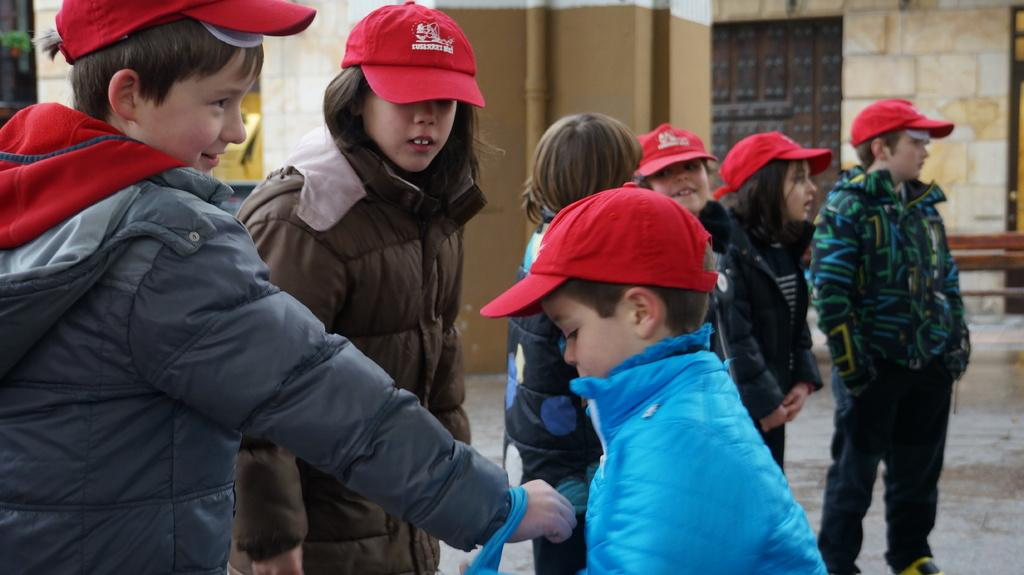What is the location of the kids in the image? The kids are on the floor in the image. What are the kids wearing? The kids are wearing jackets, and some of them are wearing caps. What can be seen in the background of the image? There is a wall in the background. What piece of furniture is on the right side of the floor? There is a bench on the right side of the floor. What type of education can be seen in the image? There is no reference to education in the image; it features kids on the floor wearing jackets and caps, with a wall in the background and a bench on the right side of the floor. How many goldfish are visible in the image? There are no goldfish present in the image. 